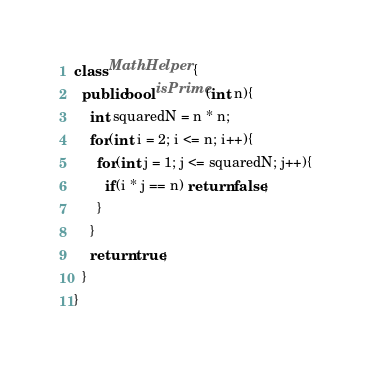Convert code to text. <code><loc_0><loc_0><loc_500><loc_500><_C#_>class MathHelper {
  public bool isPrime(int n){
    int squaredN = n * n;
    for(int i = 2; i <= n; i++){
      for(int j = 1; j <= squaredN; j++){
        if(i * j == n) return false;
      }
    }
    return true;
  }
}
</code> 